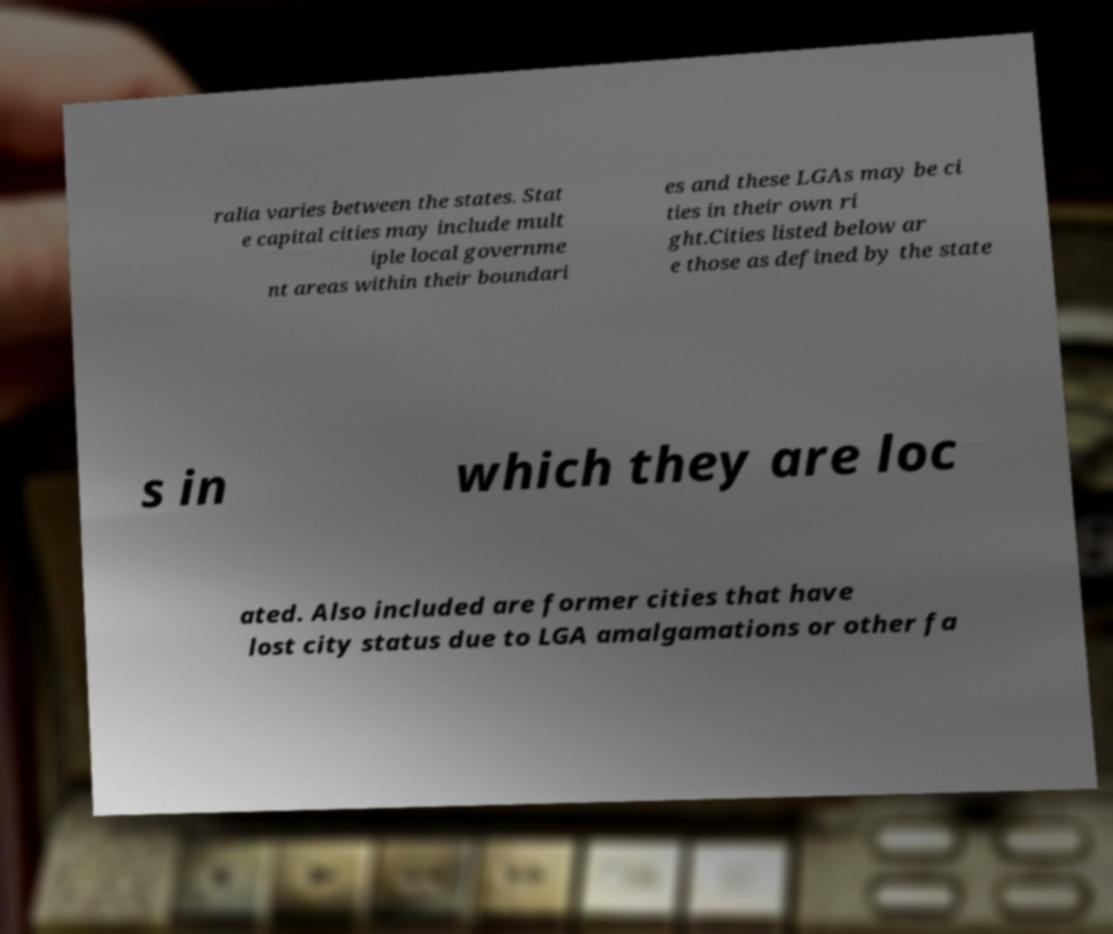Please read and relay the text visible in this image. What does it say? ralia varies between the states. Stat e capital cities may include mult iple local governme nt areas within their boundari es and these LGAs may be ci ties in their own ri ght.Cities listed below ar e those as defined by the state s in which they are loc ated. Also included are former cities that have lost city status due to LGA amalgamations or other fa 